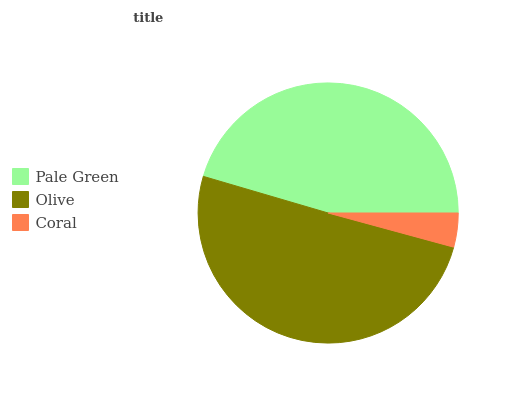Is Coral the minimum?
Answer yes or no. Yes. Is Olive the maximum?
Answer yes or no. Yes. Is Olive the minimum?
Answer yes or no. No. Is Coral the maximum?
Answer yes or no. No. Is Olive greater than Coral?
Answer yes or no. Yes. Is Coral less than Olive?
Answer yes or no. Yes. Is Coral greater than Olive?
Answer yes or no. No. Is Olive less than Coral?
Answer yes or no. No. Is Pale Green the high median?
Answer yes or no. Yes. Is Pale Green the low median?
Answer yes or no. Yes. Is Olive the high median?
Answer yes or no. No. Is Olive the low median?
Answer yes or no. No. 